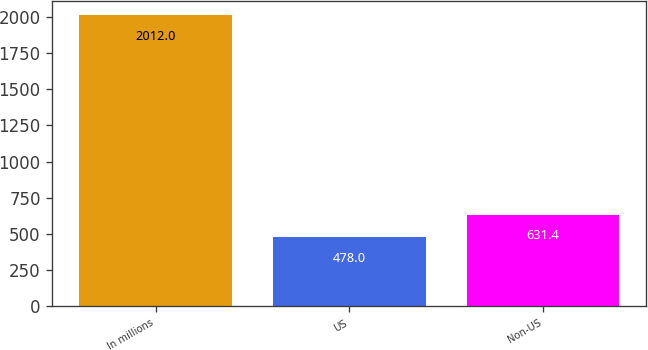Convert chart. <chart><loc_0><loc_0><loc_500><loc_500><bar_chart><fcel>In millions<fcel>US<fcel>Non-US<nl><fcel>2012<fcel>478<fcel>631.4<nl></chart> 